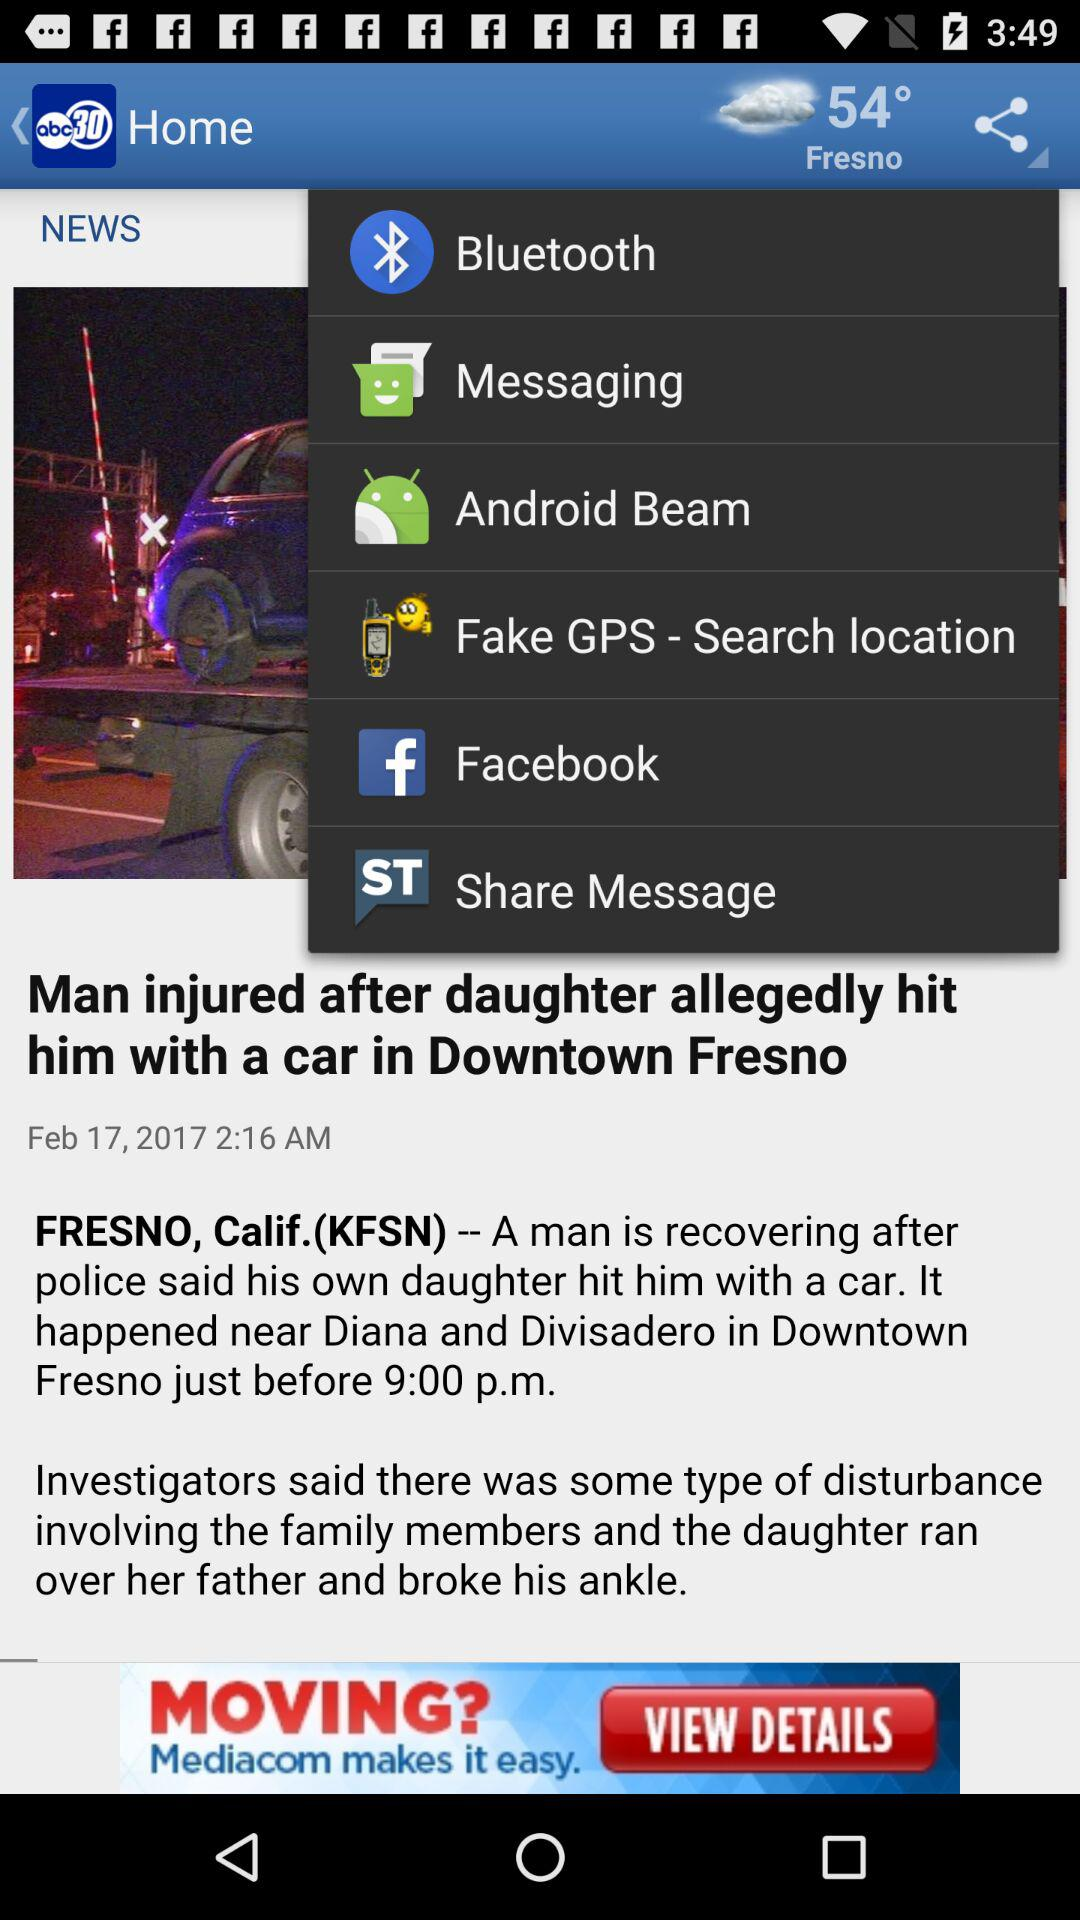When was the news "Man injured after daughter allegedly hit him with a car in Downtown Fresno" posted? The news was posted on February 17, 2017 at 2:16 am. 